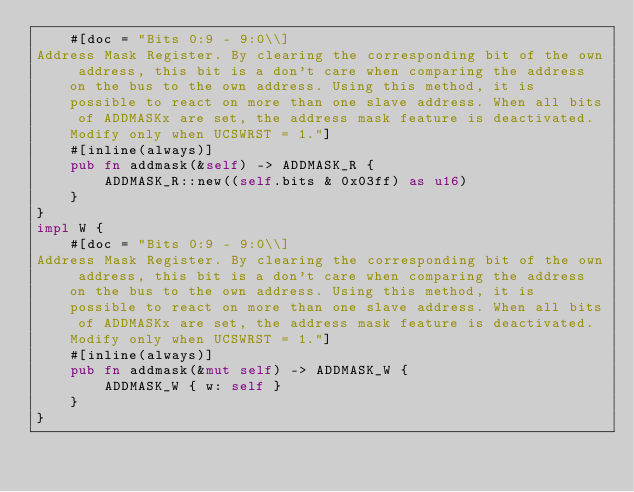<code> <loc_0><loc_0><loc_500><loc_500><_Rust_>    #[doc = "Bits 0:9 - 9:0\\]
Address Mask Register. By clearing the corresponding bit of the own address, this bit is a don't care when comparing the address on the bus to the own address. Using this method, it is possible to react on more than one slave address. When all bits of ADDMASKx are set, the address mask feature is deactivated. Modify only when UCSWRST = 1."]
    #[inline(always)]
    pub fn addmask(&self) -> ADDMASK_R {
        ADDMASK_R::new((self.bits & 0x03ff) as u16)
    }
}
impl W {
    #[doc = "Bits 0:9 - 9:0\\]
Address Mask Register. By clearing the corresponding bit of the own address, this bit is a don't care when comparing the address on the bus to the own address. Using this method, it is possible to react on more than one slave address. When all bits of ADDMASKx are set, the address mask feature is deactivated. Modify only when UCSWRST = 1."]
    #[inline(always)]
    pub fn addmask(&mut self) -> ADDMASK_W {
        ADDMASK_W { w: self }
    }
}
</code> 